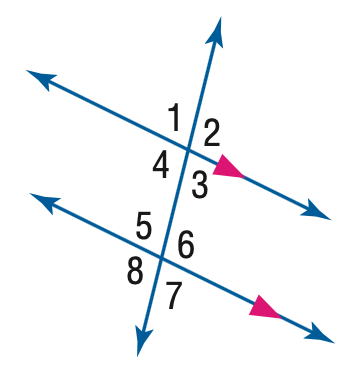Question: In the figure, m \angle 4 = 101. Find the measure of \angle 5.
Choices:
A. 69
B. 79
C. 89
D. 101
Answer with the letter. Answer: B 